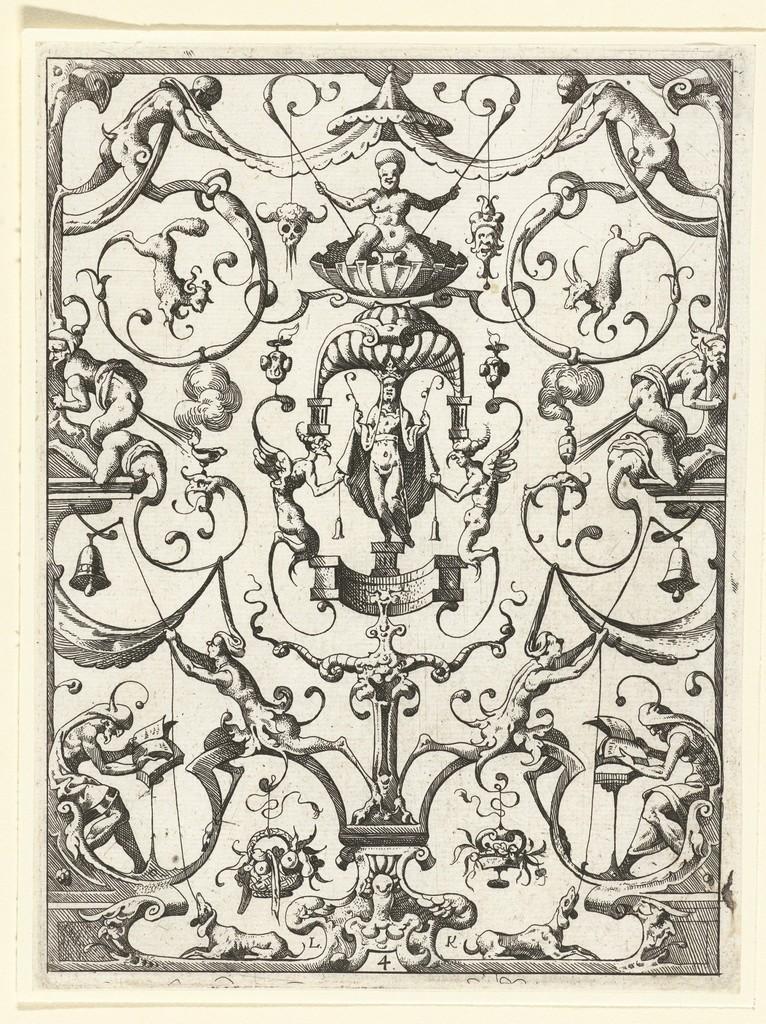In one or two sentences, can you explain what this image depicts? In the image it seems like there are different pictures on a paper. 